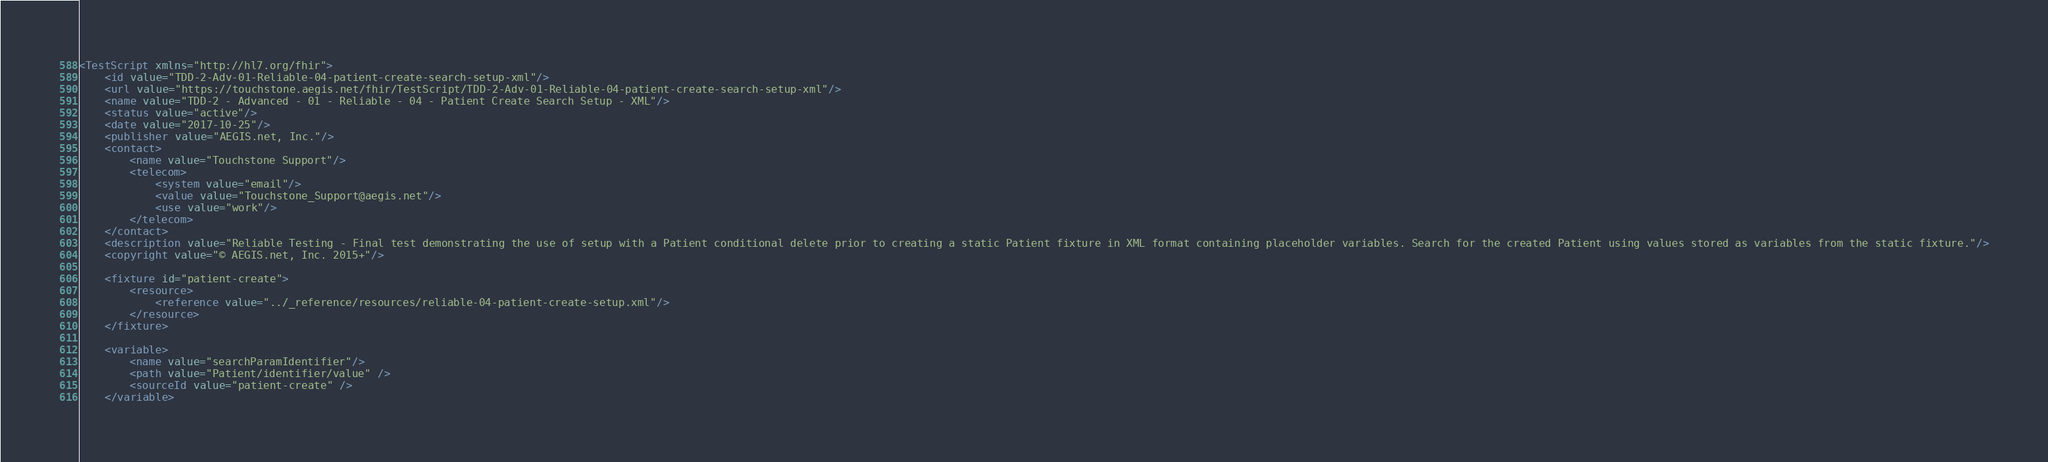Convert code to text. <code><loc_0><loc_0><loc_500><loc_500><_XML_><TestScript xmlns="http://hl7.org/fhir">
	<id value="TDD-2-Adv-01-Reliable-04-patient-create-search-setup-xml"/>
	<url value="https://touchstone.aegis.net/fhir/TestScript/TDD-2-Adv-01-Reliable-04-patient-create-search-setup-xml"/>
	<name value="TDD-2 - Advanced - 01 - Reliable - 04 - Patient Create Search Setup - XML"/>
	<status value="active"/>
	<date value="2017-10-25"/>
	<publisher value="AEGIS.net, Inc."/>
	<contact>
		<name value="Touchstone Support"/>
		<telecom>
			<system value="email"/>
			<value value="Touchstone_Support@aegis.net"/>
			<use value="work"/>
		</telecom>
	</contact>
	<description value="Reliable Testing - Final test demonstrating the use of setup with a Patient conditional delete prior to creating a static Patient fixture in XML format containing placeholder variables. Search for the created Patient using values stored as variables from the static fixture."/>
	<copyright value="© AEGIS.net, Inc. 2015+"/>

	<fixture id="patient-create">
		<resource>
			<reference value="../_reference/resources/reliable-04-patient-create-setup.xml"/>
		</resource>
	</fixture>

	<variable>
		<name value="searchParamIdentifier"/>
		<path value="Patient/identifier/value" />
		<sourceId value="patient-create" />
	</variable></code> 